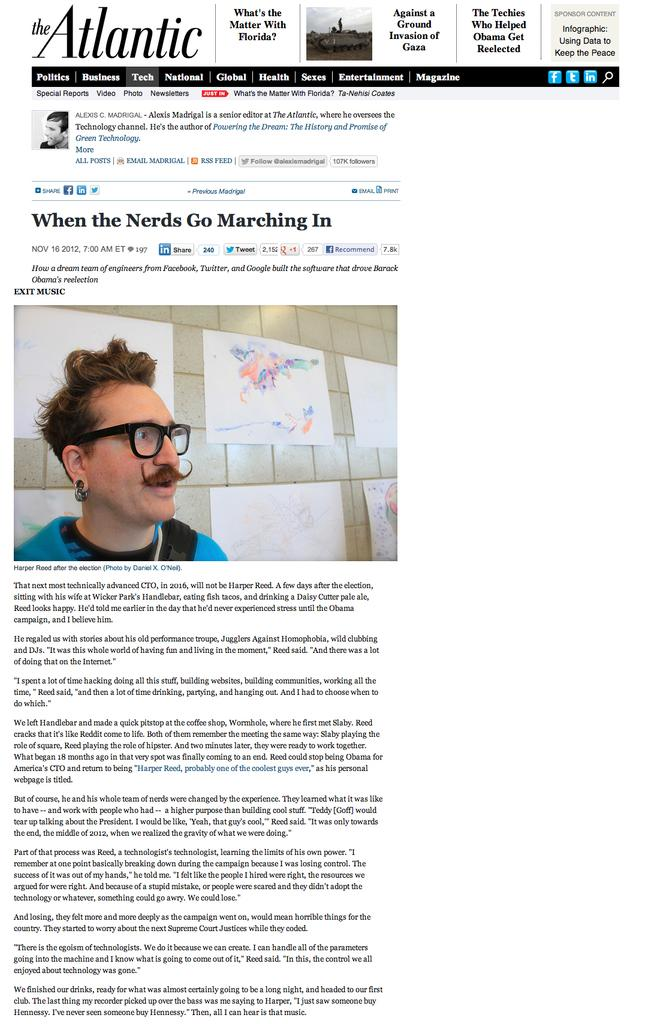What type of content is displayed in the image? The image is a snapshot of a website. What can be seen on the website besides text? There is an image of a person on the website. What type of information is available on the website? There is text on the website. Where is the cannon located on the website? There is no cannon present on the website; it only contains an image of a person and text. What type of vase is displayed on the website? There is no vase present on the website; it only contains an image of a person and text. 